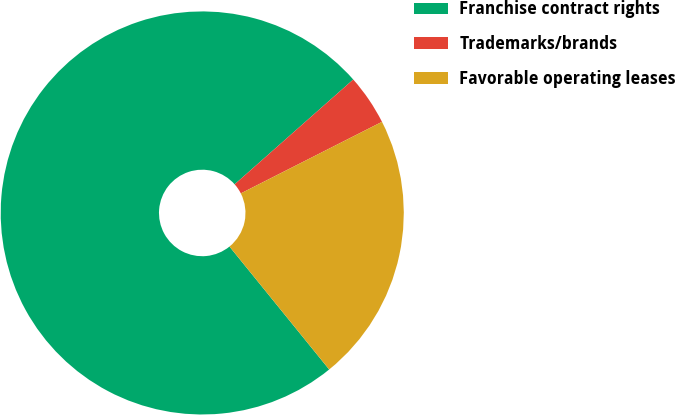Convert chart to OTSL. <chart><loc_0><loc_0><loc_500><loc_500><pie_chart><fcel>Franchise contract rights<fcel>Trademarks/brands<fcel>Favorable operating leases<nl><fcel>74.32%<fcel>4.05%<fcel>21.62%<nl></chart> 